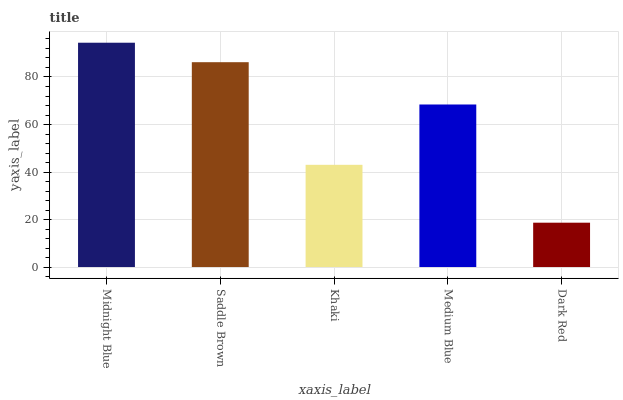Is Saddle Brown the minimum?
Answer yes or no. No. Is Saddle Brown the maximum?
Answer yes or no. No. Is Midnight Blue greater than Saddle Brown?
Answer yes or no. Yes. Is Saddle Brown less than Midnight Blue?
Answer yes or no. Yes. Is Saddle Brown greater than Midnight Blue?
Answer yes or no. No. Is Midnight Blue less than Saddle Brown?
Answer yes or no. No. Is Medium Blue the high median?
Answer yes or no. Yes. Is Medium Blue the low median?
Answer yes or no. Yes. Is Dark Red the high median?
Answer yes or no. No. Is Midnight Blue the low median?
Answer yes or no. No. 